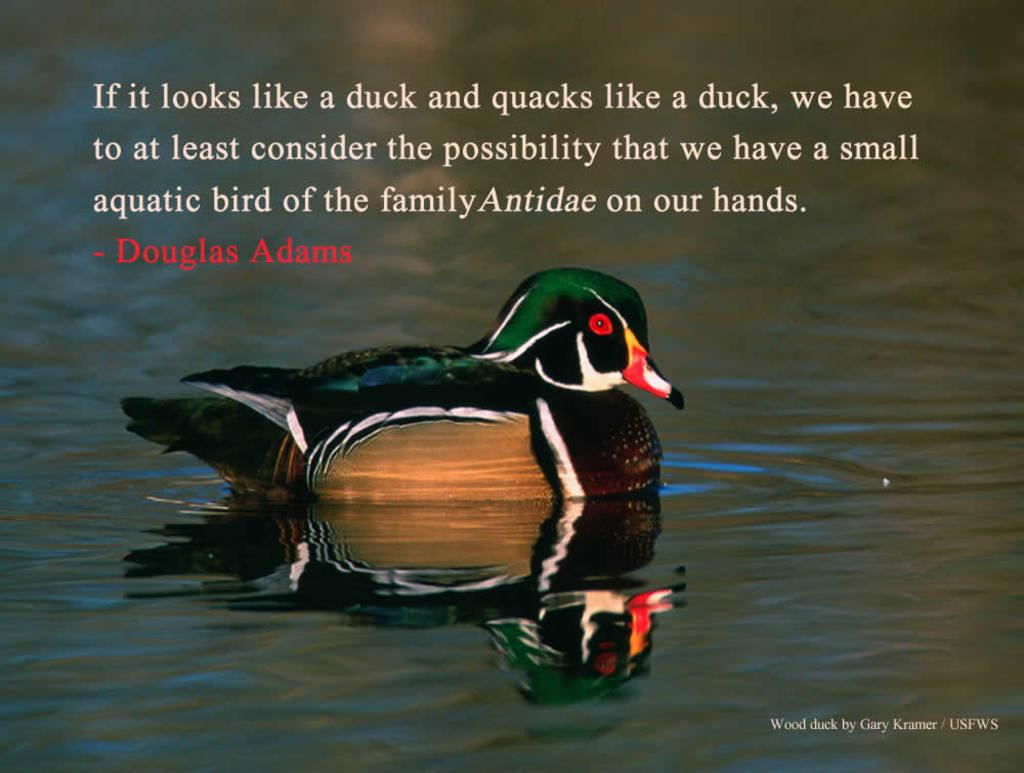What is the bird doing in the image? The bird is in the water in the image. Can you describe the appearance of the bird? The bird has multiple colors, including black, white, green, brown, red, and yellow. What else can be seen in the image besides the bird? There is text or writing present in the image. What type of sand can be seen on the tray in the image? There is no sand or tray present in the image; it features a bird in the water and text or writing. 